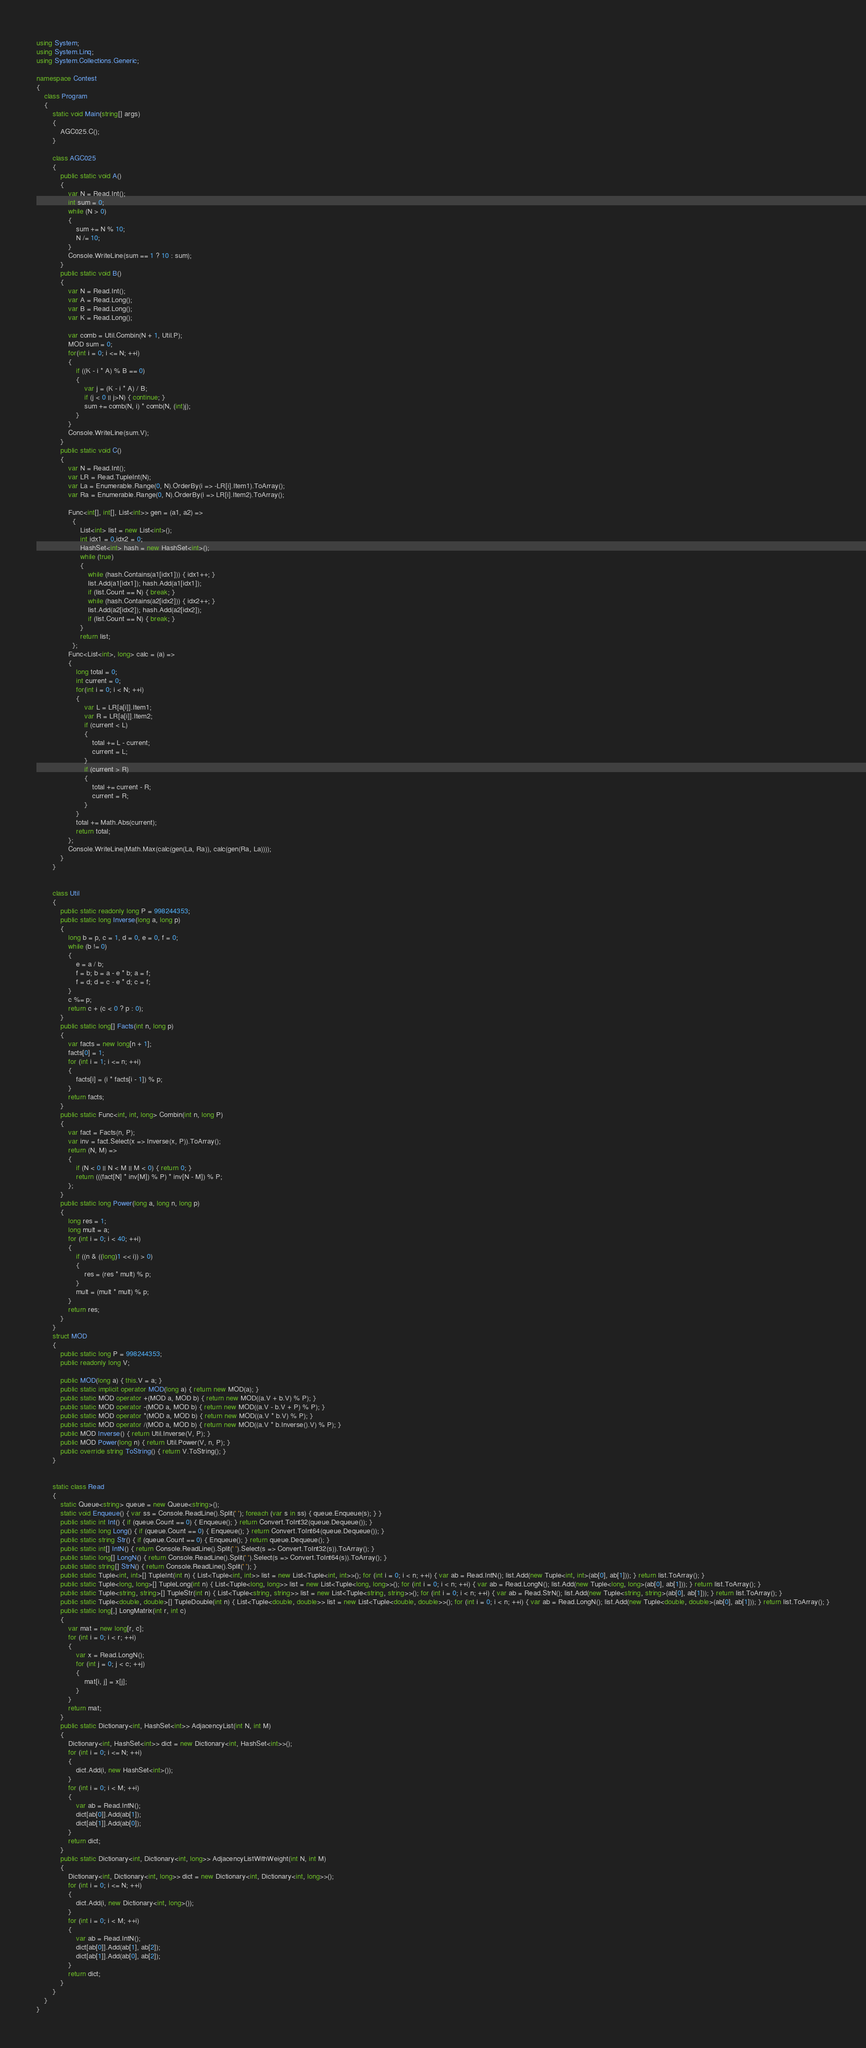<code> <loc_0><loc_0><loc_500><loc_500><_C#_>using System;
using System.Linq;
using System.Collections.Generic;

namespace Contest
{
    class Program
    {
        static void Main(string[] args)
        {
            AGC025.C();
        }

        class AGC025
        {
            public static void A()
            {
                var N = Read.Int();
                int sum = 0;
                while (N > 0)
                {
                    sum += N % 10;
                    N /= 10;
                }
                Console.WriteLine(sum == 1 ? 10 : sum);
            }
            public static void B()
            {
                var N = Read.Int();
                var A = Read.Long();
                var B = Read.Long();
                var K = Read.Long();

                var comb = Util.Combin(N + 1, Util.P);
                MOD sum = 0;
                for(int i = 0; i <= N; ++i)
                {
                    if ((K - i * A) % B == 0)
                    {
                        var j = (K - i * A) / B;
                        if (j < 0 || j>N) { continue; }
                        sum += comb(N, i) * comb(N, (int)j);
                    }
                }
                Console.WriteLine(sum.V);
            }
            public static void C()
            {
                var N = Read.Int();
                var LR = Read.TupleInt(N);
                var La = Enumerable.Range(0, N).OrderBy(i => -LR[i].Item1).ToArray();
                var Ra = Enumerable.Range(0, N).OrderBy(i => LR[i].Item2).ToArray();

                Func<int[], int[], List<int>> gen = (a1, a2) =>
                  {
                      List<int> list = new List<int>();
                      int idx1 = 0,idx2 = 0;
                      HashSet<int> hash = new HashSet<int>();
                      while (true)
                      {
                          while (hash.Contains(a1[idx1])) { idx1++; }
                          list.Add(a1[idx1]); hash.Add(a1[idx1]);
                          if (list.Count == N) { break; }
                          while (hash.Contains(a2[idx2])) { idx2++; }
                          list.Add(a2[idx2]); hash.Add(a2[idx2]);
                          if (list.Count == N) { break; }
                      }
                      return list;
                  };
                Func<List<int>, long> calc = (a) =>
                {
                    long total = 0;
                    int current = 0;
                    for(int i = 0; i < N; ++i)
                    {
                        var L = LR[a[i]].Item1;
                        var R = LR[a[i]].Item2;
                        if (current < L)
                        {
                            total += L - current;
                            current = L;
                        }
                        if (current > R)
                        {
                            total += current - R;
                            current = R;
                        }
                    }
                    total += Math.Abs(current);
                    return total;
                };
                Console.WriteLine(Math.Max(calc(gen(La, Ra)), calc(gen(Ra, La))));
            }
        }


        class Util
        {
            public static readonly long P = 998244353;
            public static long Inverse(long a, long p)
            {
                long b = p, c = 1, d = 0, e = 0, f = 0;
                while (b != 0)
                {
                    e = a / b;
                    f = b; b = a - e * b; a = f;
                    f = d; d = c - e * d; c = f;
                }
                c %= p;
                return c + (c < 0 ? p : 0);
            }
            public static long[] Facts(int n, long p)
            {
                var facts = new long[n + 1];
                facts[0] = 1;
                for (int i = 1; i <= n; ++i)
                {
                    facts[i] = (i * facts[i - 1]) % p;
                }
                return facts;
            }
            public static Func<int, int, long> Combin(int n, long P)
            {
                var fact = Facts(n, P);
                var inv = fact.Select(x => Inverse(x, P)).ToArray();
                return (N, M) =>
                {
                    if (N < 0 || N < M || M < 0) { return 0; }
                    return (((fact[N] * inv[M]) % P) * inv[N - M]) % P;
                };
            }
            public static long Power(long a, long n, long p)
            {
                long res = 1;
                long mult = a;
                for (int i = 0; i < 40; ++i)
                {
                    if ((n & ((long)1 << i)) > 0)
                    {
                        res = (res * mult) % p;
                    }
                    mult = (mult * mult) % p;
                }
                return res;
            }
        }
        struct MOD
        {
            public static long P = 998244353;
            public readonly long V;

            public MOD(long a) { this.V = a; }
            public static implicit operator MOD(long a) { return new MOD(a); }
            public static MOD operator +(MOD a, MOD b) { return new MOD((a.V + b.V) % P); }
            public static MOD operator -(MOD a, MOD b) { return new MOD((a.V - b.V + P) % P); }
            public static MOD operator *(MOD a, MOD b) { return new MOD((a.V * b.V) % P); }
            public static MOD operator /(MOD a, MOD b) { return new MOD((a.V * b.Inverse().V) % P); }
            public MOD Inverse() { return Util.Inverse(V, P); }
            public MOD Power(long n) { return Util.Power(V, n, P); }
            public override string ToString() { return V.ToString(); }
        }


        static class Read
        {
            static Queue<string> queue = new Queue<string>();
            static void Enqueue() { var ss = Console.ReadLine().Split(' '); foreach (var s in ss) { queue.Enqueue(s); } }
            public static int Int() { if (queue.Count == 0) { Enqueue(); } return Convert.ToInt32(queue.Dequeue()); }
            public static long Long() { if (queue.Count == 0) { Enqueue(); } return Convert.ToInt64(queue.Dequeue()); }
            public static string Str() { if (queue.Count == 0) { Enqueue(); } return queue.Dequeue(); }
            public static int[] IntN() { return Console.ReadLine().Split(' ').Select(s => Convert.ToInt32(s)).ToArray(); }
            public static long[] LongN() { return Console.ReadLine().Split(' ').Select(s => Convert.ToInt64(s)).ToArray(); }
            public static string[] StrN() { return Console.ReadLine().Split(' '); }
            public static Tuple<int, int>[] TupleInt(int n) { List<Tuple<int, int>> list = new List<Tuple<int, int>>(); for (int i = 0; i < n; ++i) { var ab = Read.IntN(); list.Add(new Tuple<int, int>(ab[0], ab[1])); } return list.ToArray(); }
            public static Tuple<long, long>[] TupleLong(int n) { List<Tuple<long, long>> list = new List<Tuple<long, long>>(); for (int i = 0; i < n; ++i) { var ab = Read.LongN(); list.Add(new Tuple<long, long>(ab[0], ab[1])); } return list.ToArray(); }
            public static Tuple<string, string>[] TupleStr(int n) { List<Tuple<string, string>> list = new List<Tuple<string, string>>(); for (int i = 0; i < n; ++i) { var ab = Read.StrN(); list.Add(new Tuple<string, string>(ab[0], ab[1])); } return list.ToArray(); }
            public static Tuple<double, double>[] TupleDouble(int n) { List<Tuple<double, double>> list = new List<Tuple<double, double>>(); for (int i = 0; i < n; ++i) { var ab = Read.LongN(); list.Add(new Tuple<double, double>(ab[0], ab[1])); } return list.ToArray(); }
            public static long[,] LongMatrix(int r, int c)
            {
                var mat = new long[r, c];
                for (int i = 0; i < r; ++i)
                {
                    var x = Read.LongN();
                    for (int j = 0; j < c; ++j)
                    {
                        mat[i, j] = x[j];
                    }
                }
                return mat;
            }
            public static Dictionary<int, HashSet<int>> AdjacencyList(int N, int M)
            {
                Dictionary<int, HashSet<int>> dict = new Dictionary<int, HashSet<int>>();
                for (int i = 0; i <= N; ++i)
                {
                    dict.Add(i, new HashSet<int>());
                }
                for (int i = 0; i < M; ++i)
                {
                    var ab = Read.IntN();
                    dict[ab[0]].Add(ab[1]);
                    dict[ab[1]].Add(ab[0]);
                }
                return dict;
            }
            public static Dictionary<int, Dictionary<int, long>> AdjacencyListWithWeight(int N, int M)
            {
                Dictionary<int, Dictionary<int, long>> dict = new Dictionary<int, Dictionary<int, long>>();
                for (int i = 0; i <= N; ++i)
                {
                    dict.Add(i, new Dictionary<int, long>());
                }
                for (int i = 0; i < M; ++i)
                {
                    var ab = Read.IntN();
                    dict[ab[0]].Add(ab[1], ab[2]);
                    dict[ab[1]].Add(ab[0], ab[2]);
                }
                return dict;
            }
        }
    }
}
</code> 